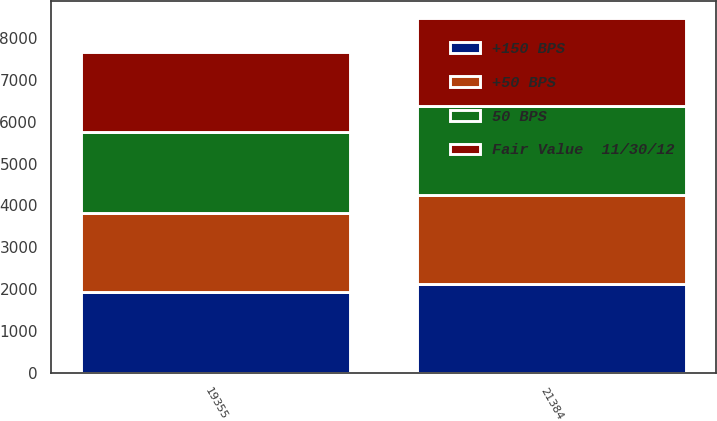Convert chart to OTSL. <chart><loc_0><loc_0><loc_500><loc_500><stacked_bar_chart><ecel><fcel>21384<fcel>19355<nl><fcel>50 BPS<fcel>2136.6<fcel>1930.6<nl><fcel>+150 BPS<fcel>2129.3<fcel>1922.1<nl><fcel>+50 BPS<fcel>2113.1<fcel>1909.9<nl><fcel>Fair Value  11/30/12<fcel>2094.6<fcel>1896.4<nl></chart> 